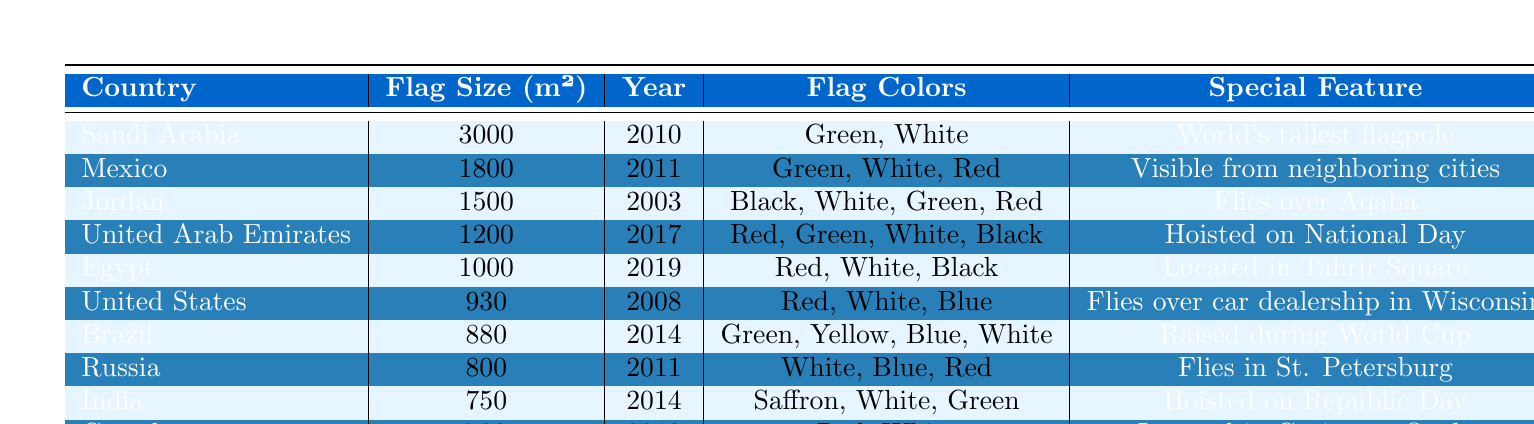What is the flag size of Saudi Arabia? The table lists the flag size of Saudi Arabia as 3000 square meters.
Answer: 3000 Which country has the second largest flag? According to the table, Mexico has the second largest flag size at 1800 square meters.
Answer: Mexico What year was the United States flag introduced? The table indicates that the United States flag was introduced in 2008.
Answer: 2008 How many colors are in the Brazilian flag? The table shows that the Brazilian flag has four colors: Green, Yellow, Blue, and White.
Answer: Four Which flag is located in Tahrir Square? From the table, we can see that the flag located in Tahrir Square is that of Egypt.
Answer: Egypt Is the Jordanian flag larger than the Canadian flag? The table indicates that the Jordanian flag size is 1500 square meters while the Canadian flag is 700 square meters, so yes, it is larger.
Answer: Yes What is the difference in flag size between India and Russia? The flag size for India is 750 square meters and for Russia is 800 square meters. The difference is 800 - 750 = 50 square meters.
Answer: 50 List the countries with flags larger than 900 square meters. Referring to the table, the countries with flags larger than 900 square meters are Saudi Arabia, Mexico, Jordan, United Arab Emirates, Egypt, and the United States.
Answer: Saudi Arabia, Mexico, Jordan, United Arab Emirates, Egypt, United States Which flag was introduced most recently and what is its size? According to the table, the most recently introduced flag is that of Egypt in 2019, with a size of 1000 square meters.
Answer: 1000, Egypt How many flags have Red as one of their colors? By checking the table, the flags from Mexico, United Arab Emirates, Egypt, United States, Brazil, and Canada have Red as one of their colors. This gives a total of six flags.
Answer: Six 